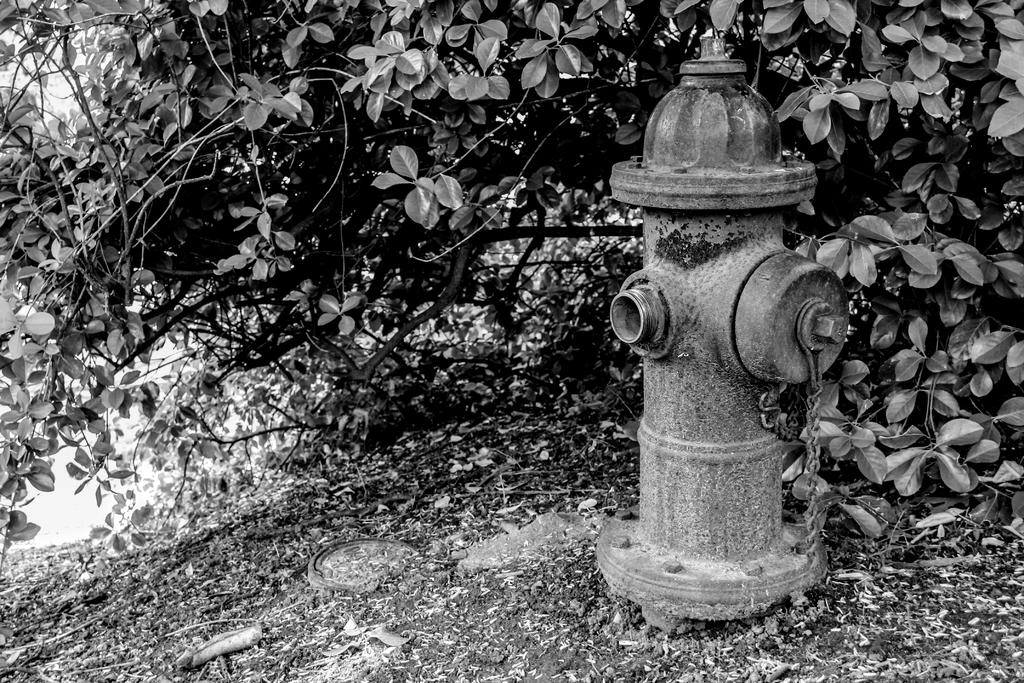What object is the main subject of the image? There is a fire hydrant in the image. Where is the fire hydrant located? The fire hydrant is on the land. What type of vegetation can be seen in the background of the image? There are plants with leaves in the background of the image. What type of bottle can be seen in the image? There is no bottle present in the image. 